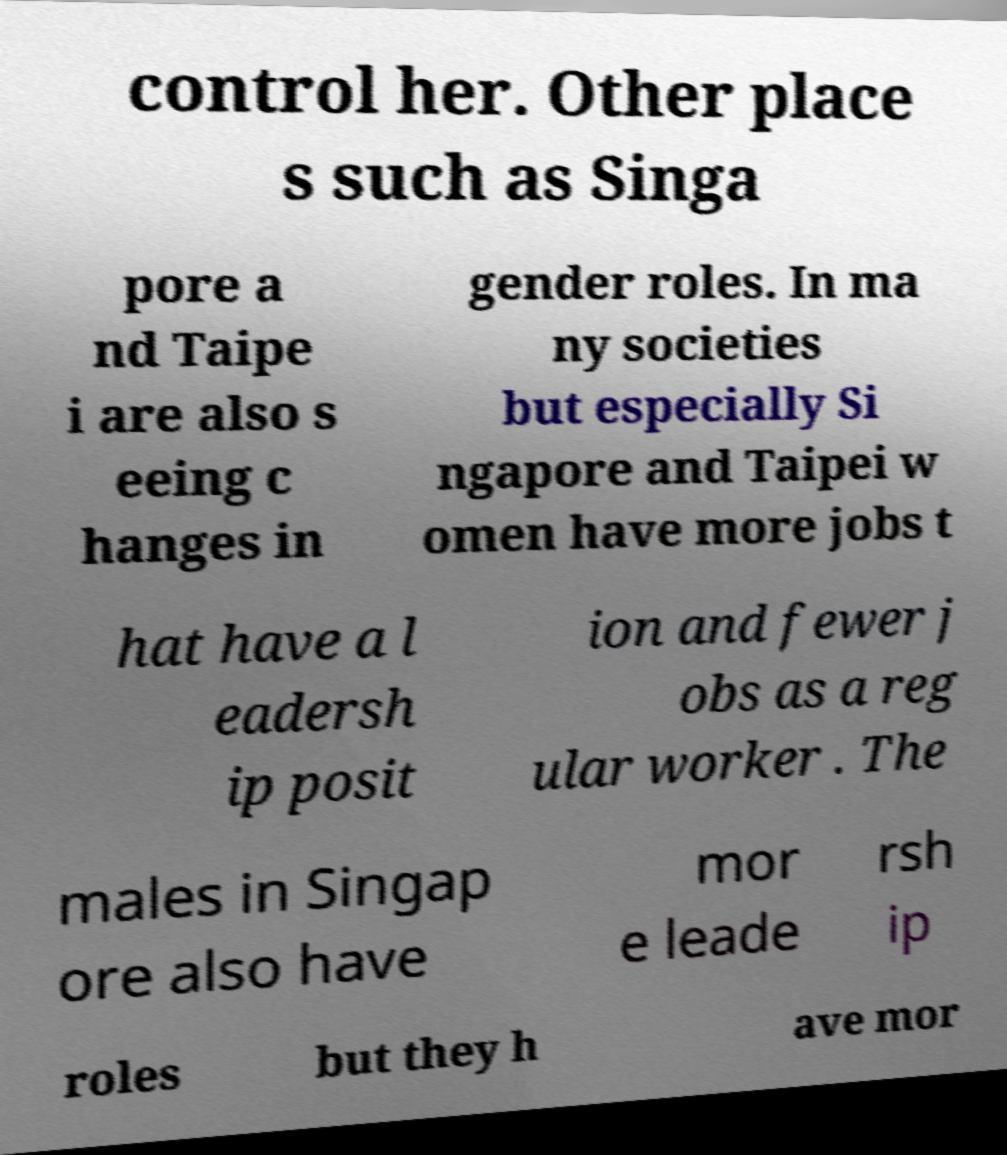Please identify and transcribe the text found in this image. control her. Other place s such as Singa pore a nd Taipe i are also s eeing c hanges in gender roles. In ma ny societies but especially Si ngapore and Taipei w omen have more jobs t hat have a l eadersh ip posit ion and fewer j obs as a reg ular worker . The males in Singap ore also have mor e leade rsh ip roles but they h ave mor 